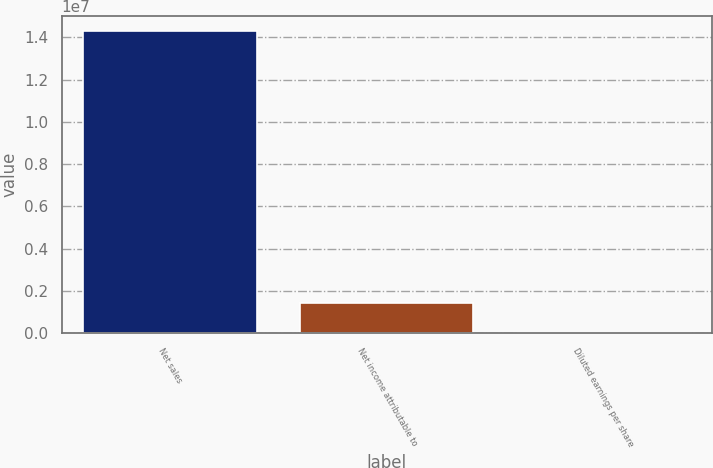Convert chart to OTSL. <chart><loc_0><loc_0><loc_500><loc_500><bar_chart><fcel>Net sales<fcel>Net income attributable to<fcel>Diluted earnings per share<nl><fcel>1.43024e+07<fcel>1.43025e+06<fcel>7.83<nl></chart> 